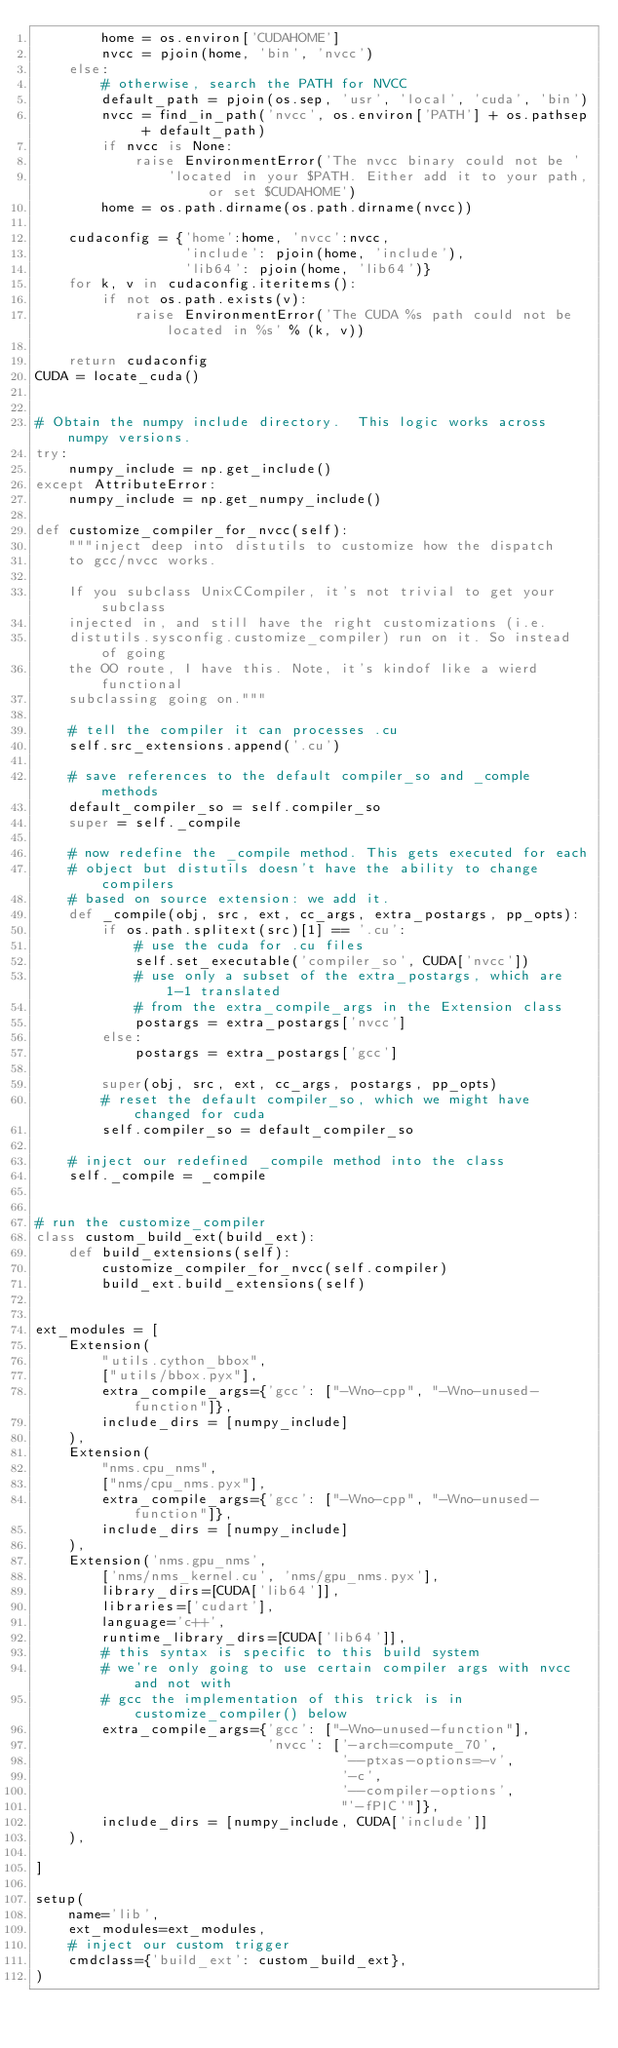<code> <loc_0><loc_0><loc_500><loc_500><_Python_>        home = os.environ['CUDAHOME']
        nvcc = pjoin(home, 'bin', 'nvcc')
    else:
        # otherwise, search the PATH for NVCC
        default_path = pjoin(os.sep, 'usr', 'local', 'cuda', 'bin')
        nvcc = find_in_path('nvcc', os.environ['PATH'] + os.pathsep + default_path)
        if nvcc is None:
            raise EnvironmentError('The nvcc binary could not be '
                'located in your $PATH. Either add it to your path, or set $CUDAHOME')
        home = os.path.dirname(os.path.dirname(nvcc))

    cudaconfig = {'home':home, 'nvcc':nvcc,
                  'include': pjoin(home, 'include'),
                  'lib64': pjoin(home, 'lib64')}
    for k, v in cudaconfig.iteritems():
        if not os.path.exists(v):
            raise EnvironmentError('The CUDA %s path could not be located in %s' % (k, v))

    return cudaconfig
CUDA = locate_cuda()


# Obtain the numpy include directory.  This logic works across numpy versions.
try:
    numpy_include = np.get_include()
except AttributeError:
    numpy_include = np.get_numpy_include()

def customize_compiler_for_nvcc(self):
    """inject deep into distutils to customize how the dispatch
    to gcc/nvcc works.

    If you subclass UnixCCompiler, it's not trivial to get your subclass
    injected in, and still have the right customizations (i.e.
    distutils.sysconfig.customize_compiler) run on it. So instead of going
    the OO route, I have this. Note, it's kindof like a wierd functional
    subclassing going on."""

    # tell the compiler it can processes .cu
    self.src_extensions.append('.cu')

    # save references to the default compiler_so and _comple methods
    default_compiler_so = self.compiler_so
    super = self._compile

    # now redefine the _compile method. This gets executed for each
    # object but distutils doesn't have the ability to change compilers
    # based on source extension: we add it.
    def _compile(obj, src, ext, cc_args, extra_postargs, pp_opts):
        if os.path.splitext(src)[1] == '.cu':
            # use the cuda for .cu files
            self.set_executable('compiler_so', CUDA['nvcc'])
            # use only a subset of the extra_postargs, which are 1-1 translated
            # from the extra_compile_args in the Extension class
            postargs = extra_postargs['nvcc']
        else:
            postargs = extra_postargs['gcc']

        super(obj, src, ext, cc_args, postargs, pp_opts)
        # reset the default compiler_so, which we might have changed for cuda
        self.compiler_so = default_compiler_so

    # inject our redefined _compile method into the class
    self._compile = _compile


# run the customize_compiler
class custom_build_ext(build_ext):
    def build_extensions(self):
        customize_compiler_for_nvcc(self.compiler)
        build_ext.build_extensions(self)


ext_modules = [
    Extension(
        "utils.cython_bbox",
        ["utils/bbox.pyx"],
        extra_compile_args={'gcc': ["-Wno-cpp", "-Wno-unused-function"]},
        include_dirs = [numpy_include]
    ),
    Extension(
        "nms.cpu_nms",
        ["nms/cpu_nms.pyx"],
        extra_compile_args={'gcc': ["-Wno-cpp", "-Wno-unused-function"]},
        include_dirs = [numpy_include]
    ),
    Extension('nms.gpu_nms',
        ['nms/nms_kernel.cu', 'nms/gpu_nms.pyx'],
        library_dirs=[CUDA['lib64']],
        libraries=['cudart'],
        language='c++',
        runtime_library_dirs=[CUDA['lib64']],
        # this syntax is specific to this build system
        # we're only going to use certain compiler args with nvcc and not with
        # gcc the implementation of this trick is in customize_compiler() below
        extra_compile_args={'gcc': ["-Wno-unused-function"],
                            'nvcc': ['-arch=compute_70',
                                     '--ptxas-options=-v',
                                     '-c',
                                     '--compiler-options',
                                     "'-fPIC'"]},
        include_dirs = [numpy_include, CUDA['include']]
    ),

]

setup(
    name='lib',
    ext_modules=ext_modules,
    # inject our custom trigger
    cmdclass={'build_ext': custom_build_ext},
)
</code> 